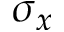<formula> <loc_0><loc_0><loc_500><loc_500>\sigma _ { x }</formula> 